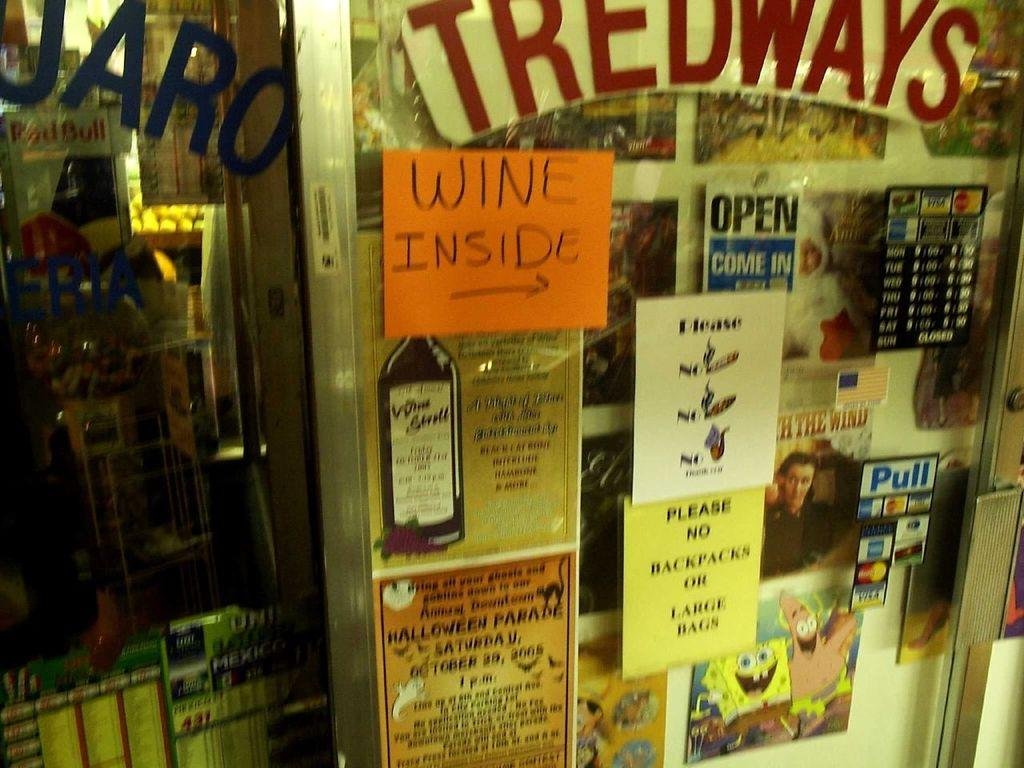<image>
Describe the image concisely. Tredways sells wine but does not allow backpacks or large bags. 